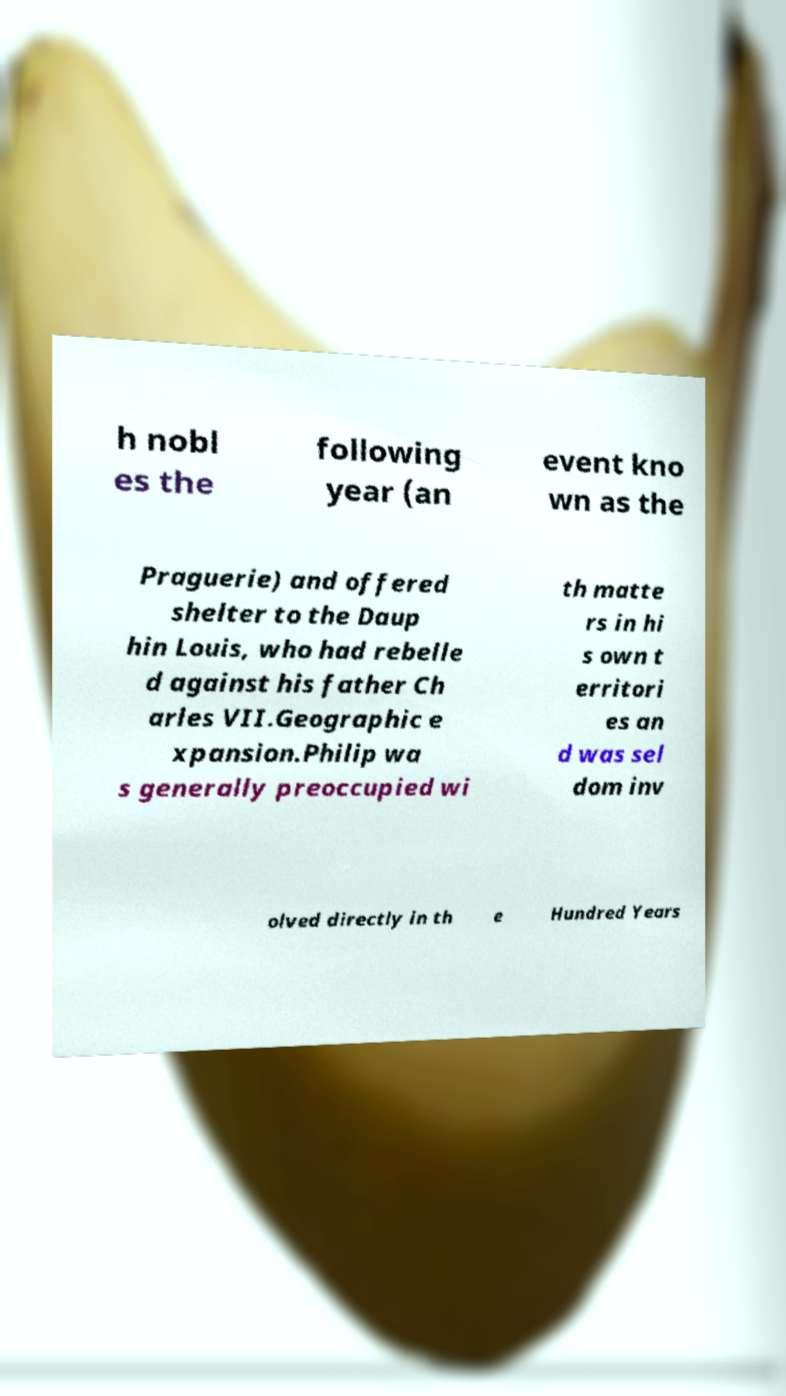Could you assist in decoding the text presented in this image and type it out clearly? h nobl es the following year (an event kno wn as the Praguerie) and offered shelter to the Daup hin Louis, who had rebelle d against his father Ch arles VII.Geographic e xpansion.Philip wa s generally preoccupied wi th matte rs in hi s own t erritori es an d was sel dom inv olved directly in th e Hundred Years 